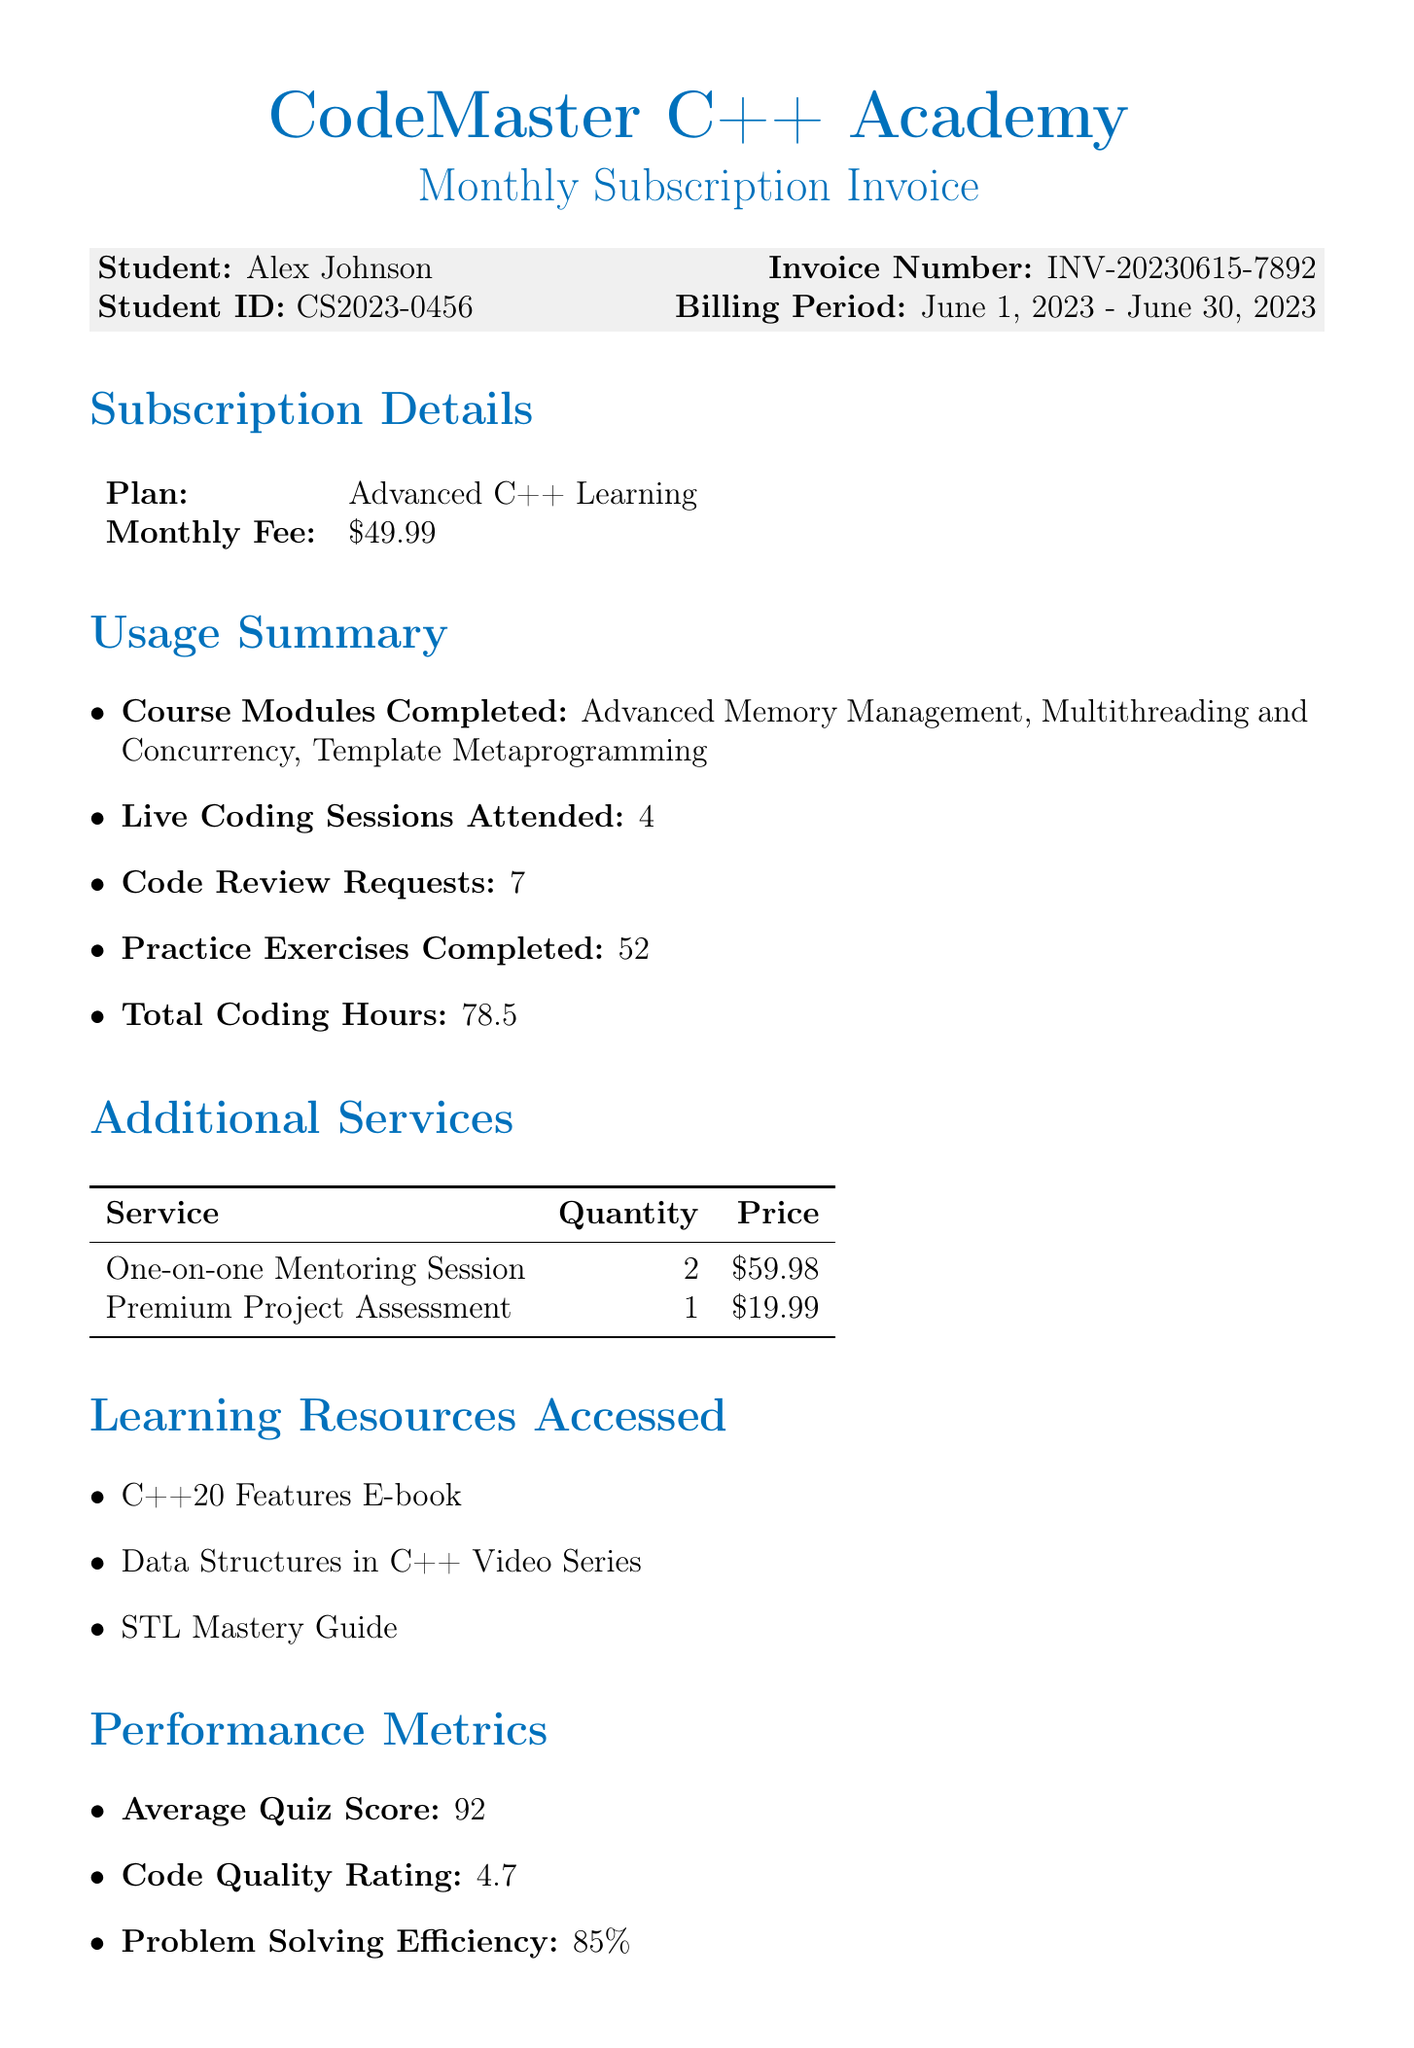What is the platform name? The platform name is mentioned at the beginning of the document.
Answer: CodeMaster C++ Academy Who is the student? The document specifies the name of the student for whom the invoice is issued.
Answer: Alex Johnson What is the total amount due? The total amount due is calculated and presented in the billing summary section of the document.
Answer: 129.96 How many live coding sessions were attended? The document provides a summary of the usage metrics, including the number of live coding sessions attended.
Answer: 4 What is the billing period? The billing period specifies the time frame for which the invoice is applicable, and it is clearly stated in the document.
Answer: June 1, 2023 - June 30, 2023 What is the average quiz score? The performance metrics section provides various evaluation scores, including the average quiz score.
Answer: 92 How many practice exercises were completed? This information is presented in the usage summary section of the document as a measure of student activity.
Answer: 52 What is the next billing date? The document specifies the upcoming billing date at the end of the invoice.
Answer: July 1, 2023 What is one of the special offers available? Specific special offers are listed in the document, indicating promotions for the student.
Answer: Upgrade to Annual Plan and Save 20% 